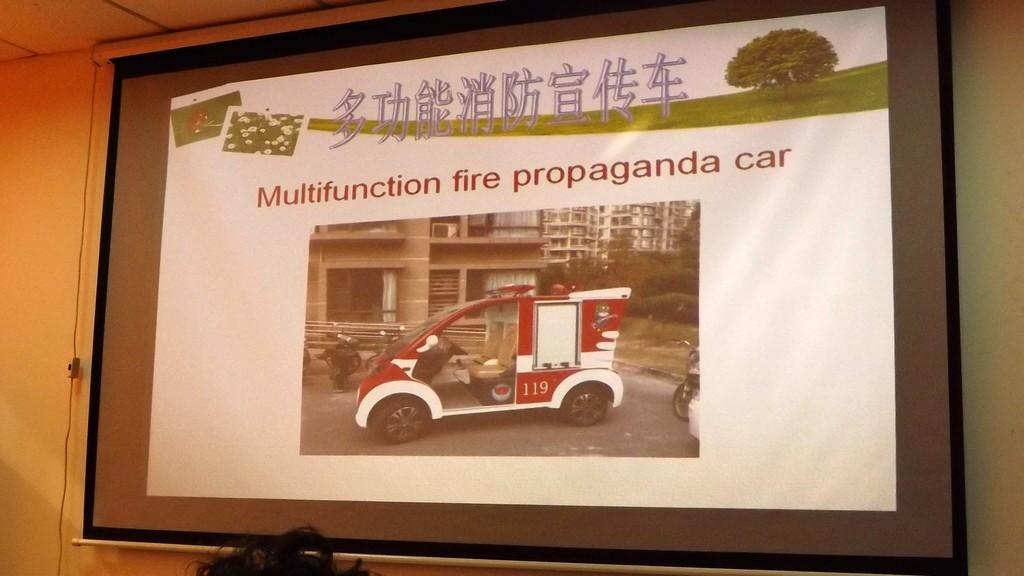Describe this image in one or two sentences. In this picture we can see screen and wall. At the bottom of the image we can see hair. 